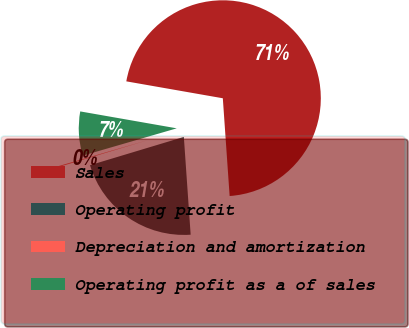Convert chart to OTSL. <chart><loc_0><loc_0><loc_500><loc_500><pie_chart><fcel>Sales<fcel>Operating profit<fcel>Depreciation and amortization<fcel>Operating profit as a of sales<nl><fcel>71.13%<fcel>21.45%<fcel>0.16%<fcel>7.26%<nl></chart> 